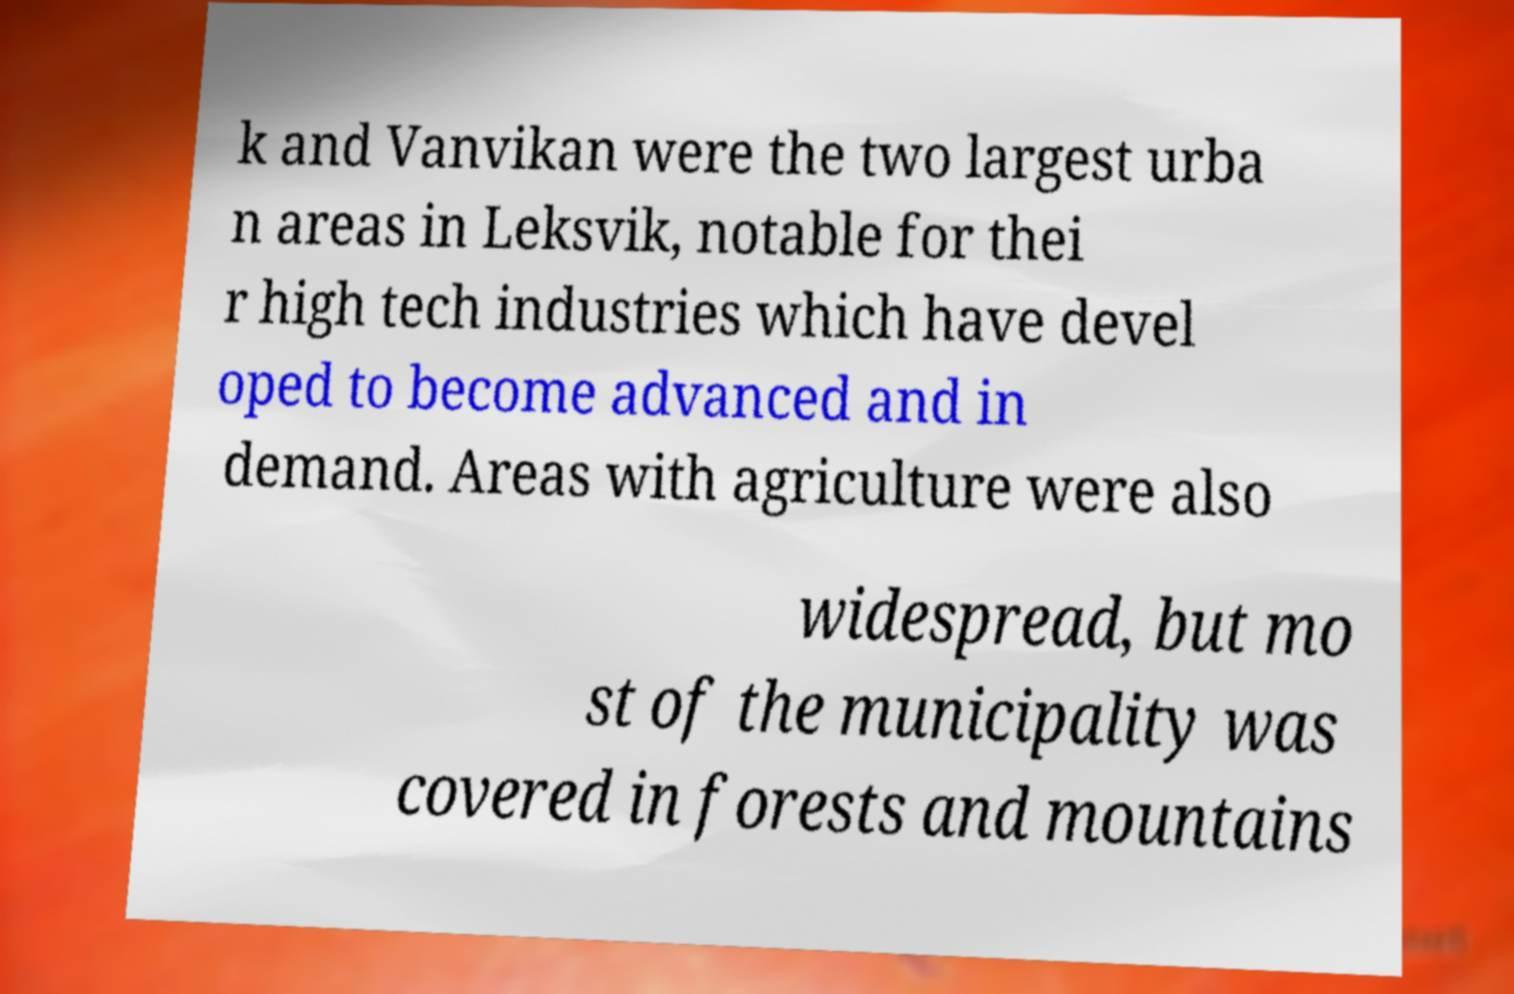Can you read and provide the text displayed in the image?This photo seems to have some interesting text. Can you extract and type it out for me? k and Vanvikan were the two largest urba n areas in Leksvik, notable for thei r high tech industries which have devel oped to become advanced and in demand. Areas with agriculture were also widespread, but mo st of the municipality was covered in forests and mountains 